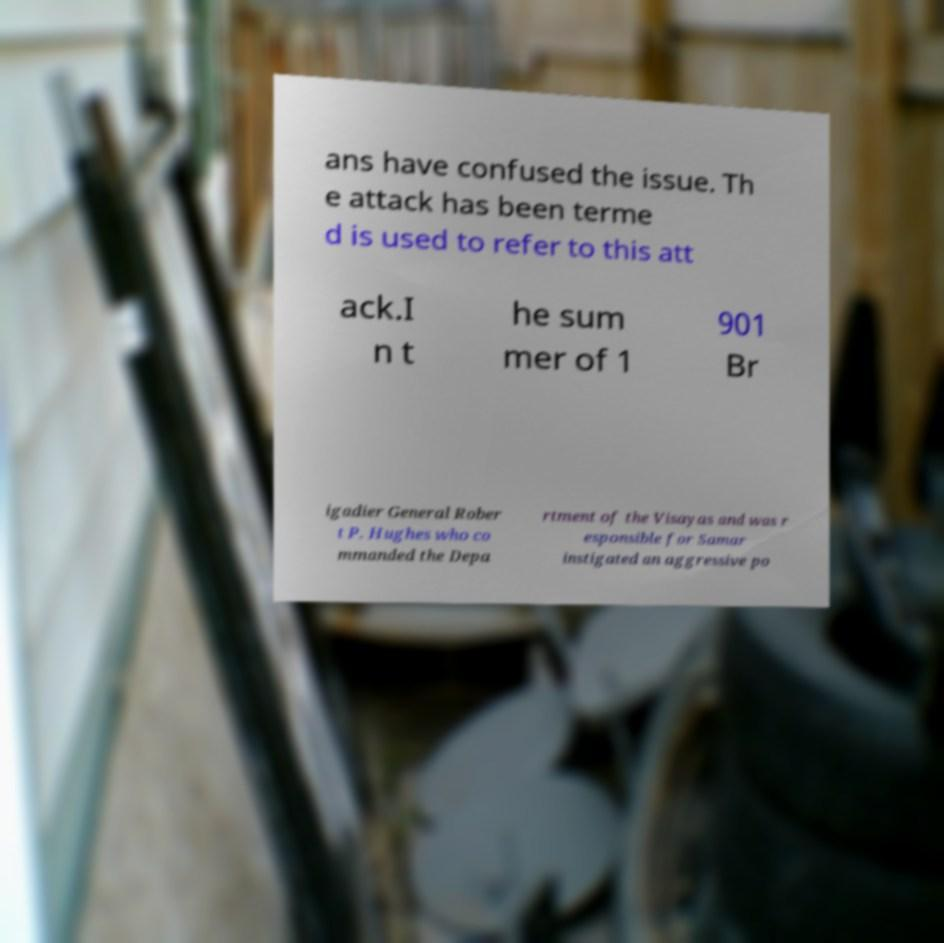Could you assist in decoding the text presented in this image and type it out clearly? ans have confused the issue. Th e attack has been terme d is used to refer to this att ack.I n t he sum mer of 1 901 Br igadier General Rober t P. Hughes who co mmanded the Depa rtment of the Visayas and was r esponsible for Samar instigated an aggressive po 